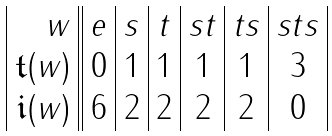Convert formula to latex. <formula><loc_0><loc_0><loc_500><loc_500>\begin{array} { | r | | c | c | c | c | c | c | } w & e & s & t & s t & t s & s t s \\ \mathfrak { t } ( w ) & 0 & 1 & 1 & 1 & 1 & 3 \\ \mathfrak { i } ( w ) & 6 & 2 & 2 & 2 & 2 & 0 \\ \end{array}</formula> 